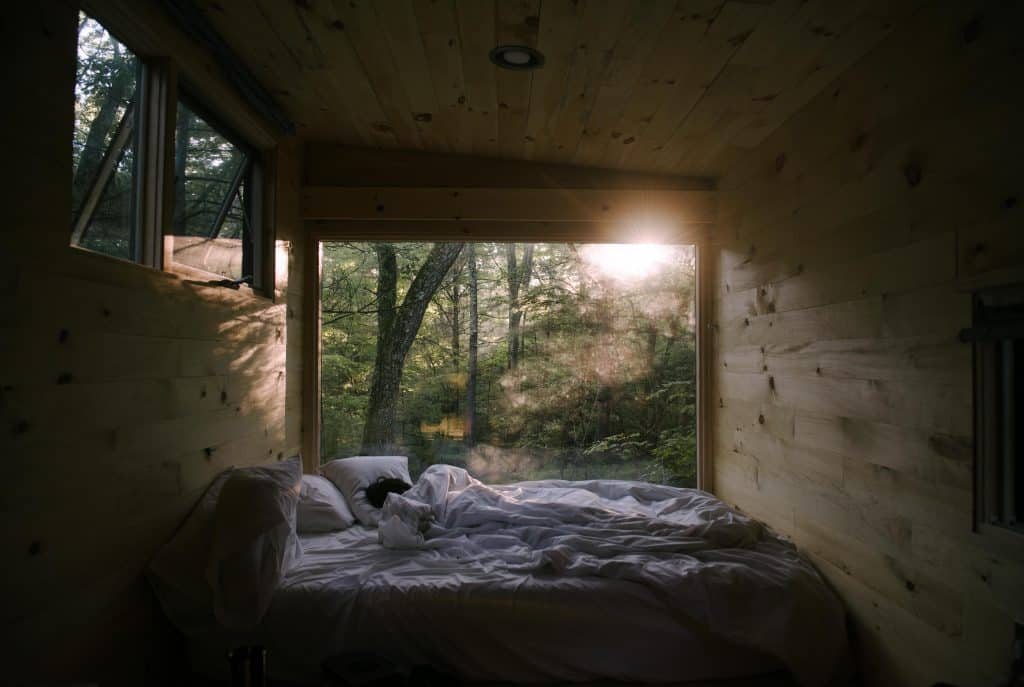Considering the positioning of the bed in relation to the windows, what can be inferred about the priorities in the design of this bedroom? The positioning of the bed, placed directly between two large windows, suggests that the design prioritizes a connection with the natural surroundings. The bed's orientation allows occupants to wake up to a view of the forest, which can be both visually pleasing and psychologically soothing. This setup indicates that the experience of the natural environment is considered an essential element of the bedroom's design, likely aiming to provide a tranquil and restorative space for rest and relaxation. 